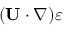Convert formula to latex. <formula><loc_0><loc_0><loc_500><loc_500>( { U } \cdot \nabla ) \varepsilon</formula> 